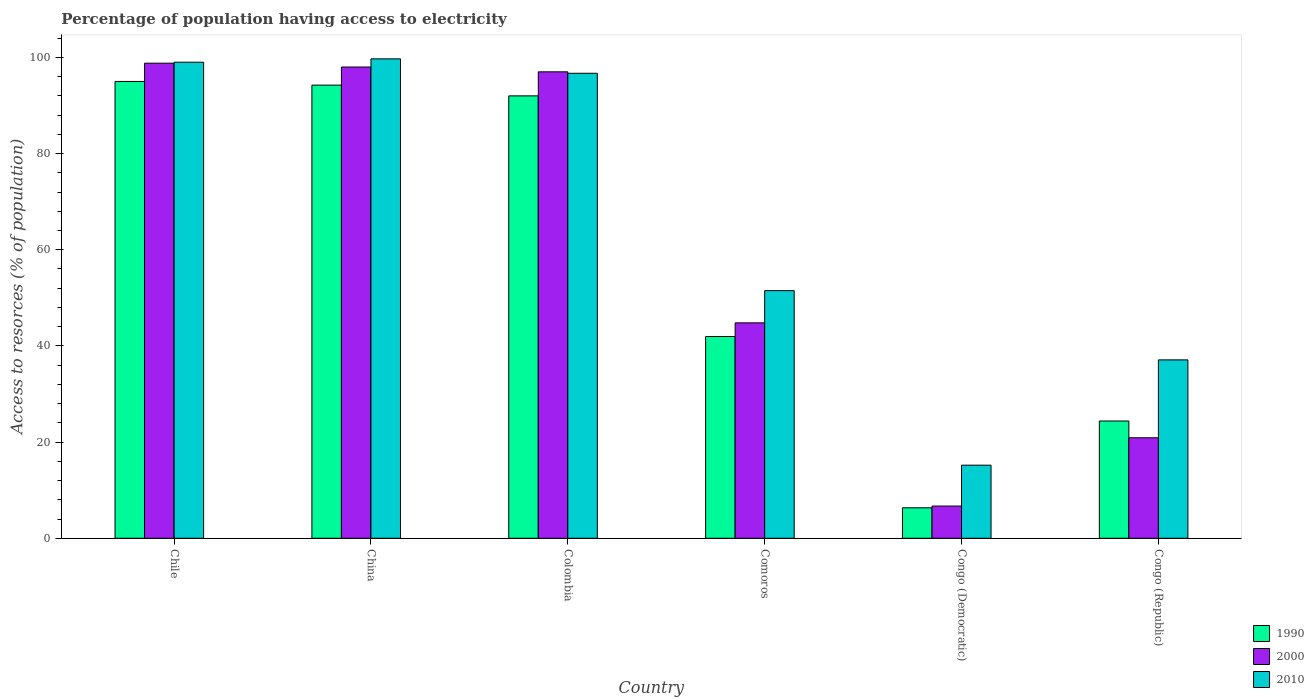How many different coloured bars are there?
Keep it short and to the point. 3. How many groups of bars are there?
Keep it short and to the point. 6. Are the number of bars per tick equal to the number of legend labels?
Offer a very short reply. Yes. Are the number of bars on each tick of the X-axis equal?
Give a very brief answer. Yes. How many bars are there on the 4th tick from the left?
Your answer should be very brief. 3. How many bars are there on the 4th tick from the right?
Your answer should be very brief. 3. What is the label of the 5th group of bars from the left?
Offer a very short reply. Congo (Democratic). What is the percentage of population having access to electricity in 2000 in Colombia?
Ensure brevity in your answer.  97. Across all countries, what is the minimum percentage of population having access to electricity in 2000?
Provide a succinct answer. 6.7. In which country was the percentage of population having access to electricity in 1990 minimum?
Your answer should be compact. Congo (Democratic). What is the total percentage of population having access to electricity in 2000 in the graph?
Provide a short and direct response. 366.2. What is the difference between the percentage of population having access to electricity in 2000 in China and that in Congo (Republic)?
Your answer should be very brief. 77.1. What is the difference between the percentage of population having access to electricity in 2000 in Colombia and the percentage of population having access to electricity in 2010 in Chile?
Your response must be concise. -2. What is the average percentage of population having access to electricity in 1990 per country?
Ensure brevity in your answer.  58.99. What is the difference between the percentage of population having access to electricity of/in 1990 and percentage of population having access to electricity of/in 2010 in Chile?
Your response must be concise. -4. What is the ratio of the percentage of population having access to electricity in 2000 in China to that in Congo (Republic)?
Offer a very short reply. 4.69. What is the difference between the highest and the second highest percentage of population having access to electricity in 2000?
Make the answer very short. -1.8. What is the difference between the highest and the lowest percentage of population having access to electricity in 2000?
Ensure brevity in your answer.  92.1. In how many countries, is the percentage of population having access to electricity in 1990 greater than the average percentage of population having access to electricity in 1990 taken over all countries?
Your answer should be very brief. 3. How many bars are there?
Make the answer very short. 18. Are all the bars in the graph horizontal?
Provide a succinct answer. No. What is the difference between two consecutive major ticks on the Y-axis?
Provide a succinct answer. 20. Are the values on the major ticks of Y-axis written in scientific E-notation?
Your answer should be compact. No. Does the graph contain grids?
Your answer should be very brief. No. Where does the legend appear in the graph?
Your answer should be very brief. Bottom right. How many legend labels are there?
Your answer should be compact. 3. What is the title of the graph?
Keep it short and to the point. Percentage of population having access to electricity. What is the label or title of the Y-axis?
Offer a terse response. Access to resorces (% of population). What is the Access to resorces (% of population) of 2000 in Chile?
Your answer should be very brief. 98.8. What is the Access to resorces (% of population) of 2010 in Chile?
Your response must be concise. 99. What is the Access to resorces (% of population) in 1990 in China?
Provide a succinct answer. 94.24. What is the Access to resorces (% of population) of 2000 in China?
Your answer should be very brief. 98. What is the Access to resorces (% of population) of 2010 in China?
Your response must be concise. 99.7. What is the Access to resorces (% of population) of 1990 in Colombia?
Offer a terse response. 92. What is the Access to resorces (% of population) of 2000 in Colombia?
Make the answer very short. 97. What is the Access to resorces (% of population) in 2010 in Colombia?
Offer a very short reply. 96.7. What is the Access to resorces (% of population) of 1990 in Comoros?
Your response must be concise. 41.96. What is the Access to resorces (% of population) in 2000 in Comoros?
Keep it short and to the point. 44.8. What is the Access to resorces (% of population) of 2010 in Comoros?
Make the answer very short. 51.5. What is the Access to resorces (% of population) in 1990 in Congo (Democratic)?
Ensure brevity in your answer.  6.34. What is the Access to resorces (% of population) in 2010 in Congo (Democratic)?
Offer a very short reply. 15.2. What is the Access to resorces (% of population) in 1990 in Congo (Republic)?
Your answer should be compact. 24.39. What is the Access to resorces (% of population) in 2000 in Congo (Republic)?
Provide a short and direct response. 20.9. What is the Access to resorces (% of population) of 2010 in Congo (Republic)?
Offer a very short reply. 37.1. Across all countries, what is the maximum Access to resorces (% of population) of 1990?
Your response must be concise. 95. Across all countries, what is the maximum Access to resorces (% of population) in 2000?
Offer a very short reply. 98.8. Across all countries, what is the maximum Access to resorces (% of population) in 2010?
Provide a short and direct response. 99.7. Across all countries, what is the minimum Access to resorces (% of population) of 1990?
Provide a succinct answer. 6.34. Across all countries, what is the minimum Access to resorces (% of population) of 2000?
Your response must be concise. 6.7. What is the total Access to resorces (% of population) in 1990 in the graph?
Your response must be concise. 353.92. What is the total Access to resorces (% of population) of 2000 in the graph?
Keep it short and to the point. 366.2. What is the total Access to resorces (% of population) of 2010 in the graph?
Your response must be concise. 399.2. What is the difference between the Access to resorces (% of population) of 1990 in Chile and that in China?
Your response must be concise. 0.76. What is the difference between the Access to resorces (% of population) in 2000 in Chile and that in China?
Give a very brief answer. 0.8. What is the difference between the Access to resorces (% of population) of 1990 in Chile and that in Comoros?
Your response must be concise. 53.04. What is the difference between the Access to resorces (% of population) of 2010 in Chile and that in Comoros?
Provide a short and direct response. 47.5. What is the difference between the Access to resorces (% of population) of 1990 in Chile and that in Congo (Democratic)?
Your response must be concise. 88.66. What is the difference between the Access to resorces (% of population) in 2000 in Chile and that in Congo (Democratic)?
Your answer should be compact. 92.1. What is the difference between the Access to resorces (% of population) of 2010 in Chile and that in Congo (Democratic)?
Your answer should be compact. 83.8. What is the difference between the Access to resorces (% of population) in 1990 in Chile and that in Congo (Republic)?
Keep it short and to the point. 70.61. What is the difference between the Access to resorces (% of population) in 2000 in Chile and that in Congo (Republic)?
Provide a short and direct response. 77.9. What is the difference between the Access to resorces (% of population) of 2010 in Chile and that in Congo (Republic)?
Your answer should be very brief. 61.9. What is the difference between the Access to resorces (% of population) of 1990 in China and that in Colombia?
Give a very brief answer. 2.24. What is the difference between the Access to resorces (% of population) in 1990 in China and that in Comoros?
Offer a terse response. 52.28. What is the difference between the Access to resorces (% of population) of 2000 in China and that in Comoros?
Your answer should be very brief. 53.2. What is the difference between the Access to resorces (% of population) in 2010 in China and that in Comoros?
Your response must be concise. 48.2. What is the difference between the Access to resorces (% of population) of 1990 in China and that in Congo (Democratic)?
Provide a short and direct response. 87.9. What is the difference between the Access to resorces (% of population) of 2000 in China and that in Congo (Democratic)?
Your response must be concise. 91.3. What is the difference between the Access to resorces (% of population) of 2010 in China and that in Congo (Democratic)?
Give a very brief answer. 84.5. What is the difference between the Access to resorces (% of population) of 1990 in China and that in Congo (Republic)?
Offer a terse response. 69.85. What is the difference between the Access to resorces (% of population) of 2000 in China and that in Congo (Republic)?
Ensure brevity in your answer.  77.1. What is the difference between the Access to resorces (% of population) in 2010 in China and that in Congo (Republic)?
Give a very brief answer. 62.6. What is the difference between the Access to resorces (% of population) of 1990 in Colombia and that in Comoros?
Provide a short and direct response. 50.04. What is the difference between the Access to resorces (% of population) of 2000 in Colombia and that in Comoros?
Your answer should be very brief. 52.2. What is the difference between the Access to resorces (% of population) of 2010 in Colombia and that in Comoros?
Offer a terse response. 45.2. What is the difference between the Access to resorces (% of population) of 1990 in Colombia and that in Congo (Democratic)?
Provide a short and direct response. 85.66. What is the difference between the Access to resorces (% of population) of 2000 in Colombia and that in Congo (Democratic)?
Your answer should be very brief. 90.3. What is the difference between the Access to resorces (% of population) of 2010 in Colombia and that in Congo (Democratic)?
Give a very brief answer. 81.5. What is the difference between the Access to resorces (% of population) of 1990 in Colombia and that in Congo (Republic)?
Give a very brief answer. 67.61. What is the difference between the Access to resorces (% of population) in 2000 in Colombia and that in Congo (Republic)?
Give a very brief answer. 76.1. What is the difference between the Access to resorces (% of population) in 2010 in Colombia and that in Congo (Republic)?
Keep it short and to the point. 59.6. What is the difference between the Access to resorces (% of population) of 1990 in Comoros and that in Congo (Democratic)?
Ensure brevity in your answer.  35.62. What is the difference between the Access to resorces (% of population) in 2000 in Comoros and that in Congo (Democratic)?
Keep it short and to the point. 38.1. What is the difference between the Access to resorces (% of population) in 2010 in Comoros and that in Congo (Democratic)?
Your answer should be very brief. 36.3. What is the difference between the Access to resorces (% of population) of 1990 in Comoros and that in Congo (Republic)?
Your response must be concise. 17.57. What is the difference between the Access to resorces (% of population) of 2000 in Comoros and that in Congo (Republic)?
Give a very brief answer. 23.9. What is the difference between the Access to resorces (% of population) in 1990 in Congo (Democratic) and that in Congo (Republic)?
Give a very brief answer. -18.05. What is the difference between the Access to resorces (% of population) of 2010 in Congo (Democratic) and that in Congo (Republic)?
Your answer should be compact. -21.9. What is the difference between the Access to resorces (% of population) of 1990 in Chile and the Access to resorces (% of population) of 2000 in China?
Provide a succinct answer. -3. What is the difference between the Access to resorces (% of population) of 2000 in Chile and the Access to resorces (% of population) of 2010 in China?
Ensure brevity in your answer.  -0.9. What is the difference between the Access to resorces (% of population) in 1990 in Chile and the Access to resorces (% of population) in 2000 in Colombia?
Offer a terse response. -2. What is the difference between the Access to resorces (% of population) in 1990 in Chile and the Access to resorces (% of population) in 2000 in Comoros?
Give a very brief answer. 50.2. What is the difference between the Access to resorces (% of population) of 1990 in Chile and the Access to resorces (% of population) of 2010 in Comoros?
Keep it short and to the point. 43.5. What is the difference between the Access to resorces (% of population) of 2000 in Chile and the Access to resorces (% of population) of 2010 in Comoros?
Provide a short and direct response. 47.3. What is the difference between the Access to resorces (% of population) of 1990 in Chile and the Access to resorces (% of population) of 2000 in Congo (Democratic)?
Provide a succinct answer. 88.3. What is the difference between the Access to resorces (% of population) of 1990 in Chile and the Access to resorces (% of population) of 2010 in Congo (Democratic)?
Offer a terse response. 79.8. What is the difference between the Access to resorces (% of population) of 2000 in Chile and the Access to resorces (% of population) of 2010 in Congo (Democratic)?
Make the answer very short. 83.6. What is the difference between the Access to resorces (% of population) in 1990 in Chile and the Access to resorces (% of population) in 2000 in Congo (Republic)?
Offer a very short reply. 74.1. What is the difference between the Access to resorces (% of population) in 1990 in Chile and the Access to resorces (% of population) in 2010 in Congo (Republic)?
Ensure brevity in your answer.  57.9. What is the difference between the Access to resorces (% of population) of 2000 in Chile and the Access to resorces (% of population) of 2010 in Congo (Republic)?
Offer a terse response. 61.7. What is the difference between the Access to resorces (% of population) in 1990 in China and the Access to resorces (% of population) in 2000 in Colombia?
Your answer should be compact. -2.76. What is the difference between the Access to resorces (% of population) of 1990 in China and the Access to resorces (% of population) of 2010 in Colombia?
Ensure brevity in your answer.  -2.46. What is the difference between the Access to resorces (% of population) of 1990 in China and the Access to resorces (% of population) of 2000 in Comoros?
Your answer should be compact. 49.44. What is the difference between the Access to resorces (% of population) of 1990 in China and the Access to resorces (% of population) of 2010 in Comoros?
Your response must be concise. 42.74. What is the difference between the Access to resorces (% of population) of 2000 in China and the Access to resorces (% of population) of 2010 in Comoros?
Your answer should be very brief. 46.5. What is the difference between the Access to resorces (% of population) of 1990 in China and the Access to resorces (% of population) of 2000 in Congo (Democratic)?
Ensure brevity in your answer.  87.54. What is the difference between the Access to resorces (% of population) in 1990 in China and the Access to resorces (% of population) in 2010 in Congo (Democratic)?
Provide a short and direct response. 79.04. What is the difference between the Access to resorces (% of population) of 2000 in China and the Access to resorces (% of population) of 2010 in Congo (Democratic)?
Offer a very short reply. 82.8. What is the difference between the Access to resorces (% of population) in 1990 in China and the Access to resorces (% of population) in 2000 in Congo (Republic)?
Provide a succinct answer. 73.34. What is the difference between the Access to resorces (% of population) of 1990 in China and the Access to resorces (% of population) of 2010 in Congo (Republic)?
Provide a succinct answer. 57.14. What is the difference between the Access to resorces (% of population) of 2000 in China and the Access to resorces (% of population) of 2010 in Congo (Republic)?
Your answer should be very brief. 60.9. What is the difference between the Access to resorces (% of population) in 1990 in Colombia and the Access to resorces (% of population) in 2000 in Comoros?
Give a very brief answer. 47.2. What is the difference between the Access to resorces (% of population) in 1990 in Colombia and the Access to resorces (% of population) in 2010 in Comoros?
Your answer should be compact. 40.5. What is the difference between the Access to resorces (% of population) in 2000 in Colombia and the Access to resorces (% of population) in 2010 in Comoros?
Ensure brevity in your answer.  45.5. What is the difference between the Access to resorces (% of population) of 1990 in Colombia and the Access to resorces (% of population) of 2000 in Congo (Democratic)?
Give a very brief answer. 85.3. What is the difference between the Access to resorces (% of population) of 1990 in Colombia and the Access to resorces (% of population) of 2010 in Congo (Democratic)?
Provide a short and direct response. 76.8. What is the difference between the Access to resorces (% of population) in 2000 in Colombia and the Access to resorces (% of population) in 2010 in Congo (Democratic)?
Offer a terse response. 81.8. What is the difference between the Access to resorces (% of population) in 1990 in Colombia and the Access to resorces (% of population) in 2000 in Congo (Republic)?
Keep it short and to the point. 71.1. What is the difference between the Access to resorces (% of population) of 1990 in Colombia and the Access to resorces (% of population) of 2010 in Congo (Republic)?
Offer a very short reply. 54.9. What is the difference between the Access to resorces (% of population) in 2000 in Colombia and the Access to resorces (% of population) in 2010 in Congo (Republic)?
Ensure brevity in your answer.  59.9. What is the difference between the Access to resorces (% of population) of 1990 in Comoros and the Access to resorces (% of population) of 2000 in Congo (Democratic)?
Offer a terse response. 35.26. What is the difference between the Access to resorces (% of population) in 1990 in Comoros and the Access to resorces (% of population) in 2010 in Congo (Democratic)?
Offer a very short reply. 26.76. What is the difference between the Access to resorces (% of population) of 2000 in Comoros and the Access to resorces (% of population) of 2010 in Congo (Democratic)?
Make the answer very short. 29.6. What is the difference between the Access to resorces (% of population) of 1990 in Comoros and the Access to resorces (% of population) of 2000 in Congo (Republic)?
Ensure brevity in your answer.  21.06. What is the difference between the Access to resorces (% of population) of 1990 in Comoros and the Access to resorces (% of population) of 2010 in Congo (Republic)?
Provide a short and direct response. 4.86. What is the difference between the Access to resorces (% of population) in 1990 in Congo (Democratic) and the Access to resorces (% of population) in 2000 in Congo (Republic)?
Offer a very short reply. -14.56. What is the difference between the Access to resorces (% of population) of 1990 in Congo (Democratic) and the Access to resorces (% of population) of 2010 in Congo (Republic)?
Ensure brevity in your answer.  -30.76. What is the difference between the Access to resorces (% of population) of 2000 in Congo (Democratic) and the Access to resorces (% of population) of 2010 in Congo (Republic)?
Offer a terse response. -30.4. What is the average Access to resorces (% of population) in 1990 per country?
Offer a terse response. 58.99. What is the average Access to resorces (% of population) in 2000 per country?
Offer a very short reply. 61.03. What is the average Access to resorces (% of population) of 2010 per country?
Provide a short and direct response. 66.53. What is the difference between the Access to resorces (% of population) in 1990 and Access to resorces (% of population) in 2000 in China?
Ensure brevity in your answer.  -3.76. What is the difference between the Access to resorces (% of population) of 1990 and Access to resorces (% of population) of 2010 in China?
Offer a very short reply. -5.46. What is the difference between the Access to resorces (% of population) of 2000 and Access to resorces (% of population) of 2010 in Colombia?
Your answer should be very brief. 0.3. What is the difference between the Access to resorces (% of population) in 1990 and Access to resorces (% of population) in 2000 in Comoros?
Give a very brief answer. -2.84. What is the difference between the Access to resorces (% of population) of 1990 and Access to resorces (% of population) of 2010 in Comoros?
Offer a very short reply. -9.54. What is the difference between the Access to resorces (% of population) of 2000 and Access to resorces (% of population) of 2010 in Comoros?
Your response must be concise. -6.7. What is the difference between the Access to resorces (% of population) in 1990 and Access to resorces (% of population) in 2000 in Congo (Democratic)?
Provide a succinct answer. -0.36. What is the difference between the Access to resorces (% of population) of 1990 and Access to resorces (% of population) of 2010 in Congo (Democratic)?
Offer a terse response. -8.86. What is the difference between the Access to resorces (% of population) of 1990 and Access to resorces (% of population) of 2000 in Congo (Republic)?
Provide a short and direct response. 3.49. What is the difference between the Access to resorces (% of population) in 1990 and Access to resorces (% of population) in 2010 in Congo (Republic)?
Provide a succinct answer. -12.71. What is the difference between the Access to resorces (% of population) of 2000 and Access to resorces (% of population) of 2010 in Congo (Republic)?
Keep it short and to the point. -16.2. What is the ratio of the Access to resorces (% of population) of 1990 in Chile to that in China?
Make the answer very short. 1.01. What is the ratio of the Access to resorces (% of population) in 2000 in Chile to that in China?
Provide a succinct answer. 1.01. What is the ratio of the Access to resorces (% of population) of 1990 in Chile to that in Colombia?
Ensure brevity in your answer.  1.03. What is the ratio of the Access to resorces (% of population) of 2000 in Chile to that in Colombia?
Ensure brevity in your answer.  1.02. What is the ratio of the Access to resorces (% of population) of 2010 in Chile to that in Colombia?
Ensure brevity in your answer.  1.02. What is the ratio of the Access to resorces (% of population) of 1990 in Chile to that in Comoros?
Ensure brevity in your answer.  2.26. What is the ratio of the Access to resorces (% of population) of 2000 in Chile to that in Comoros?
Give a very brief answer. 2.21. What is the ratio of the Access to resorces (% of population) of 2010 in Chile to that in Comoros?
Offer a terse response. 1.92. What is the ratio of the Access to resorces (% of population) of 1990 in Chile to that in Congo (Democratic)?
Provide a short and direct response. 14.99. What is the ratio of the Access to resorces (% of population) of 2000 in Chile to that in Congo (Democratic)?
Provide a succinct answer. 14.75. What is the ratio of the Access to resorces (% of population) in 2010 in Chile to that in Congo (Democratic)?
Your response must be concise. 6.51. What is the ratio of the Access to resorces (% of population) in 1990 in Chile to that in Congo (Republic)?
Provide a succinct answer. 3.9. What is the ratio of the Access to resorces (% of population) of 2000 in Chile to that in Congo (Republic)?
Ensure brevity in your answer.  4.73. What is the ratio of the Access to resorces (% of population) in 2010 in Chile to that in Congo (Republic)?
Keep it short and to the point. 2.67. What is the ratio of the Access to resorces (% of population) in 1990 in China to that in Colombia?
Your response must be concise. 1.02. What is the ratio of the Access to resorces (% of population) of 2000 in China to that in Colombia?
Offer a terse response. 1.01. What is the ratio of the Access to resorces (% of population) in 2010 in China to that in Colombia?
Offer a very short reply. 1.03. What is the ratio of the Access to resorces (% of population) of 1990 in China to that in Comoros?
Provide a short and direct response. 2.25. What is the ratio of the Access to resorces (% of population) in 2000 in China to that in Comoros?
Keep it short and to the point. 2.19. What is the ratio of the Access to resorces (% of population) in 2010 in China to that in Comoros?
Provide a succinct answer. 1.94. What is the ratio of the Access to resorces (% of population) in 1990 in China to that in Congo (Democratic)?
Ensure brevity in your answer.  14.87. What is the ratio of the Access to resorces (% of population) in 2000 in China to that in Congo (Democratic)?
Your answer should be compact. 14.63. What is the ratio of the Access to resorces (% of population) in 2010 in China to that in Congo (Democratic)?
Provide a succinct answer. 6.56. What is the ratio of the Access to resorces (% of population) of 1990 in China to that in Congo (Republic)?
Make the answer very short. 3.86. What is the ratio of the Access to resorces (% of population) in 2000 in China to that in Congo (Republic)?
Your answer should be very brief. 4.69. What is the ratio of the Access to resorces (% of population) of 2010 in China to that in Congo (Republic)?
Ensure brevity in your answer.  2.69. What is the ratio of the Access to resorces (% of population) of 1990 in Colombia to that in Comoros?
Offer a terse response. 2.19. What is the ratio of the Access to resorces (% of population) of 2000 in Colombia to that in Comoros?
Give a very brief answer. 2.17. What is the ratio of the Access to resorces (% of population) in 2010 in Colombia to that in Comoros?
Offer a very short reply. 1.88. What is the ratio of the Access to resorces (% of population) of 1990 in Colombia to that in Congo (Democratic)?
Give a very brief answer. 14.52. What is the ratio of the Access to resorces (% of population) of 2000 in Colombia to that in Congo (Democratic)?
Give a very brief answer. 14.48. What is the ratio of the Access to resorces (% of population) in 2010 in Colombia to that in Congo (Democratic)?
Provide a short and direct response. 6.36. What is the ratio of the Access to resorces (% of population) in 1990 in Colombia to that in Congo (Republic)?
Provide a short and direct response. 3.77. What is the ratio of the Access to resorces (% of population) in 2000 in Colombia to that in Congo (Republic)?
Provide a short and direct response. 4.64. What is the ratio of the Access to resorces (% of population) of 2010 in Colombia to that in Congo (Republic)?
Provide a short and direct response. 2.61. What is the ratio of the Access to resorces (% of population) of 1990 in Comoros to that in Congo (Democratic)?
Ensure brevity in your answer.  6.62. What is the ratio of the Access to resorces (% of population) in 2000 in Comoros to that in Congo (Democratic)?
Offer a terse response. 6.69. What is the ratio of the Access to resorces (% of population) in 2010 in Comoros to that in Congo (Democratic)?
Provide a succinct answer. 3.39. What is the ratio of the Access to resorces (% of population) in 1990 in Comoros to that in Congo (Republic)?
Offer a very short reply. 1.72. What is the ratio of the Access to resorces (% of population) of 2000 in Comoros to that in Congo (Republic)?
Provide a short and direct response. 2.14. What is the ratio of the Access to resorces (% of population) of 2010 in Comoros to that in Congo (Republic)?
Provide a short and direct response. 1.39. What is the ratio of the Access to resorces (% of population) in 1990 in Congo (Democratic) to that in Congo (Republic)?
Offer a very short reply. 0.26. What is the ratio of the Access to resorces (% of population) of 2000 in Congo (Democratic) to that in Congo (Republic)?
Provide a short and direct response. 0.32. What is the ratio of the Access to resorces (% of population) in 2010 in Congo (Democratic) to that in Congo (Republic)?
Offer a very short reply. 0.41. What is the difference between the highest and the second highest Access to resorces (% of population) in 1990?
Ensure brevity in your answer.  0.76. What is the difference between the highest and the lowest Access to resorces (% of population) in 1990?
Keep it short and to the point. 88.66. What is the difference between the highest and the lowest Access to resorces (% of population) of 2000?
Ensure brevity in your answer.  92.1. What is the difference between the highest and the lowest Access to resorces (% of population) in 2010?
Your answer should be very brief. 84.5. 